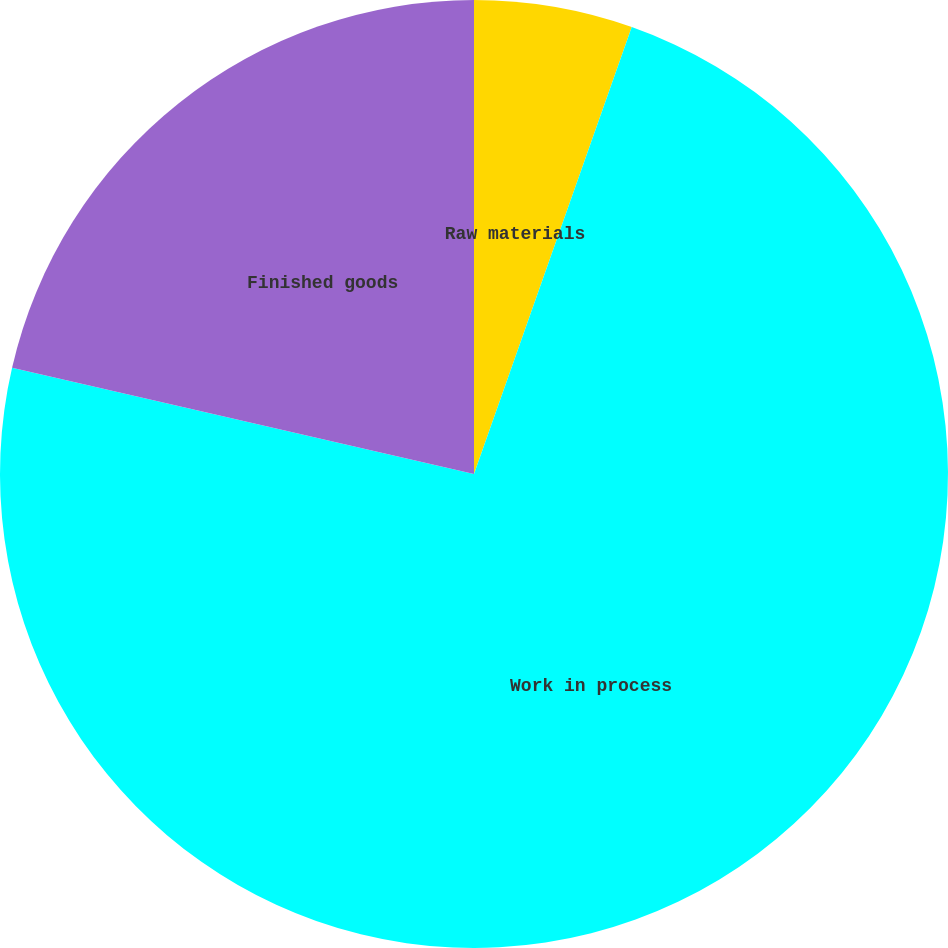Convert chart to OTSL. <chart><loc_0><loc_0><loc_500><loc_500><pie_chart><fcel>Raw materials<fcel>Work in process<fcel>Finished goods<nl><fcel>5.4%<fcel>73.2%<fcel>21.4%<nl></chart> 